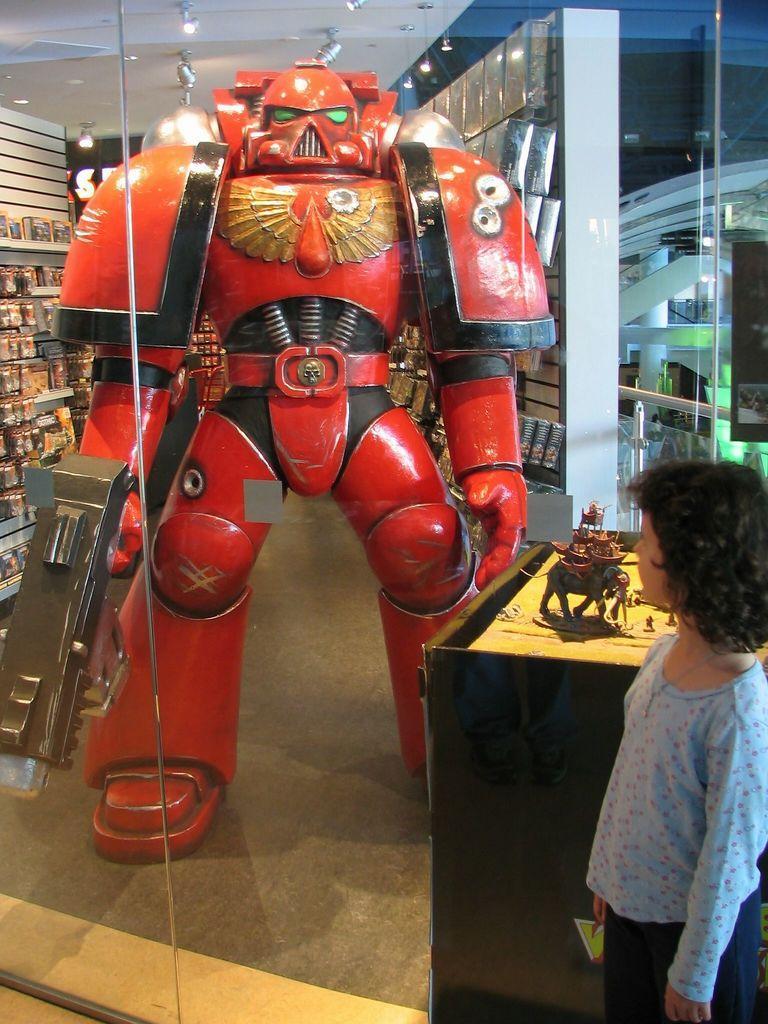Can you describe this image briefly? In this image we can see this child is standing here. Here we can see the glass doors through which we can see some objects, red color robot sculpture and in the background, we can see some objects and ceiling lights. 